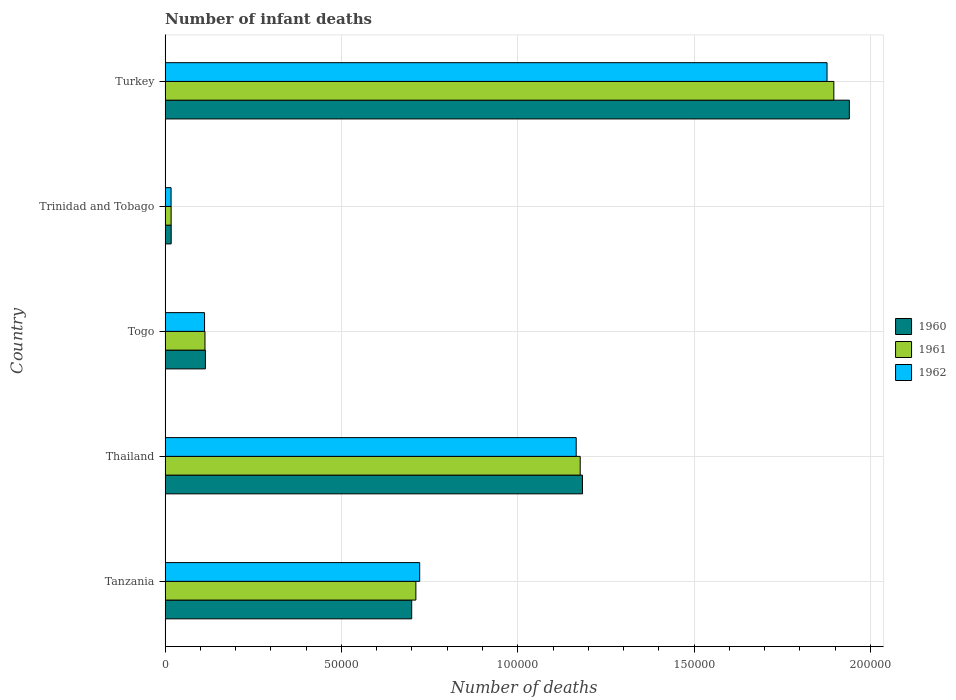Are the number of bars per tick equal to the number of legend labels?
Offer a terse response. Yes. Are the number of bars on each tick of the Y-axis equal?
Give a very brief answer. Yes. What is the label of the 3rd group of bars from the top?
Your answer should be compact. Togo. In how many cases, is the number of bars for a given country not equal to the number of legend labels?
Offer a very short reply. 0. What is the number of infant deaths in 1960 in Thailand?
Keep it short and to the point. 1.18e+05. Across all countries, what is the maximum number of infant deaths in 1960?
Offer a terse response. 1.94e+05. Across all countries, what is the minimum number of infant deaths in 1961?
Your answer should be compact. 1710. In which country was the number of infant deaths in 1961 minimum?
Offer a very short reply. Trinidad and Tobago. What is the total number of infant deaths in 1962 in the graph?
Give a very brief answer. 3.89e+05. What is the difference between the number of infant deaths in 1960 in Thailand and that in Turkey?
Your response must be concise. -7.57e+04. What is the difference between the number of infant deaths in 1961 in Togo and the number of infant deaths in 1962 in Trinidad and Tobago?
Offer a terse response. 9613. What is the average number of infant deaths in 1960 per country?
Provide a short and direct response. 7.91e+04. What is the difference between the number of infant deaths in 1960 and number of infant deaths in 1961 in Trinidad and Tobago?
Offer a terse response. 18. In how many countries, is the number of infant deaths in 1962 greater than 80000 ?
Ensure brevity in your answer.  2. What is the ratio of the number of infant deaths in 1961 in Thailand to that in Togo?
Offer a very short reply. 10.41. Is the number of infant deaths in 1961 in Togo less than that in Trinidad and Tobago?
Offer a very short reply. No. Is the difference between the number of infant deaths in 1960 in Tanzania and Thailand greater than the difference between the number of infant deaths in 1961 in Tanzania and Thailand?
Provide a short and direct response. No. What is the difference between the highest and the second highest number of infant deaths in 1962?
Make the answer very short. 7.11e+04. What is the difference between the highest and the lowest number of infant deaths in 1962?
Your answer should be very brief. 1.86e+05. In how many countries, is the number of infant deaths in 1961 greater than the average number of infant deaths in 1961 taken over all countries?
Your response must be concise. 2. What does the 2nd bar from the top in Turkey represents?
Provide a succinct answer. 1961. What does the 3rd bar from the bottom in Thailand represents?
Your answer should be compact. 1962. Is it the case that in every country, the sum of the number of infant deaths in 1962 and number of infant deaths in 1961 is greater than the number of infant deaths in 1960?
Your answer should be compact. Yes. What is the difference between two consecutive major ticks on the X-axis?
Provide a short and direct response. 5.00e+04. Are the values on the major ticks of X-axis written in scientific E-notation?
Ensure brevity in your answer.  No. Does the graph contain any zero values?
Make the answer very short. No. Does the graph contain grids?
Give a very brief answer. Yes. What is the title of the graph?
Make the answer very short. Number of infant deaths. Does "1992" appear as one of the legend labels in the graph?
Give a very brief answer. No. What is the label or title of the X-axis?
Your answer should be very brief. Number of deaths. What is the Number of deaths in 1960 in Tanzania?
Make the answer very short. 6.99e+04. What is the Number of deaths of 1961 in Tanzania?
Your response must be concise. 7.11e+04. What is the Number of deaths in 1962 in Tanzania?
Your response must be concise. 7.22e+04. What is the Number of deaths of 1960 in Thailand?
Provide a succinct answer. 1.18e+05. What is the Number of deaths of 1961 in Thailand?
Give a very brief answer. 1.18e+05. What is the Number of deaths in 1962 in Thailand?
Give a very brief answer. 1.17e+05. What is the Number of deaths in 1960 in Togo?
Make the answer very short. 1.14e+04. What is the Number of deaths of 1961 in Togo?
Provide a short and direct response. 1.13e+04. What is the Number of deaths in 1962 in Togo?
Keep it short and to the point. 1.12e+04. What is the Number of deaths of 1960 in Trinidad and Tobago?
Ensure brevity in your answer.  1728. What is the Number of deaths of 1961 in Trinidad and Tobago?
Offer a terse response. 1710. What is the Number of deaths in 1962 in Trinidad and Tobago?
Ensure brevity in your answer.  1698. What is the Number of deaths of 1960 in Turkey?
Ensure brevity in your answer.  1.94e+05. What is the Number of deaths in 1961 in Turkey?
Give a very brief answer. 1.90e+05. What is the Number of deaths in 1962 in Turkey?
Make the answer very short. 1.88e+05. Across all countries, what is the maximum Number of deaths of 1960?
Keep it short and to the point. 1.94e+05. Across all countries, what is the maximum Number of deaths of 1961?
Make the answer very short. 1.90e+05. Across all countries, what is the maximum Number of deaths of 1962?
Provide a short and direct response. 1.88e+05. Across all countries, what is the minimum Number of deaths of 1960?
Offer a terse response. 1728. Across all countries, what is the minimum Number of deaths in 1961?
Offer a terse response. 1710. Across all countries, what is the minimum Number of deaths in 1962?
Give a very brief answer. 1698. What is the total Number of deaths of 1960 in the graph?
Ensure brevity in your answer.  3.95e+05. What is the total Number of deaths in 1961 in the graph?
Make the answer very short. 3.91e+05. What is the total Number of deaths of 1962 in the graph?
Provide a succinct answer. 3.89e+05. What is the difference between the Number of deaths of 1960 in Tanzania and that in Thailand?
Make the answer very short. -4.84e+04. What is the difference between the Number of deaths in 1961 in Tanzania and that in Thailand?
Offer a terse response. -4.66e+04. What is the difference between the Number of deaths of 1962 in Tanzania and that in Thailand?
Provide a succinct answer. -4.44e+04. What is the difference between the Number of deaths of 1960 in Tanzania and that in Togo?
Provide a succinct answer. 5.85e+04. What is the difference between the Number of deaths in 1961 in Tanzania and that in Togo?
Give a very brief answer. 5.98e+04. What is the difference between the Number of deaths of 1962 in Tanzania and that in Togo?
Offer a very short reply. 6.10e+04. What is the difference between the Number of deaths of 1960 in Tanzania and that in Trinidad and Tobago?
Your answer should be compact. 6.82e+04. What is the difference between the Number of deaths of 1961 in Tanzania and that in Trinidad and Tobago?
Ensure brevity in your answer.  6.94e+04. What is the difference between the Number of deaths in 1962 in Tanzania and that in Trinidad and Tobago?
Give a very brief answer. 7.05e+04. What is the difference between the Number of deaths in 1960 in Tanzania and that in Turkey?
Keep it short and to the point. -1.24e+05. What is the difference between the Number of deaths of 1961 in Tanzania and that in Turkey?
Provide a succinct answer. -1.19e+05. What is the difference between the Number of deaths of 1962 in Tanzania and that in Turkey?
Provide a short and direct response. -1.16e+05. What is the difference between the Number of deaths in 1960 in Thailand and that in Togo?
Ensure brevity in your answer.  1.07e+05. What is the difference between the Number of deaths of 1961 in Thailand and that in Togo?
Your response must be concise. 1.06e+05. What is the difference between the Number of deaths of 1962 in Thailand and that in Togo?
Ensure brevity in your answer.  1.05e+05. What is the difference between the Number of deaths of 1960 in Thailand and that in Trinidad and Tobago?
Provide a short and direct response. 1.17e+05. What is the difference between the Number of deaths of 1961 in Thailand and that in Trinidad and Tobago?
Provide a succinct answer. 1.16e+05. What is the difference between the Number of deaths of 1962 in Thailand and that in Trinidad and Tobago?
Your answer should be very brief. 1.15e+05. What is the difference between the Number of deaths of 1960 in Thailand and that in Turkey?
Ensure brevity in your answer.  -7.57e+04. What is the difference between the Number of deaths of 1961 in Thailand and that in Turkey?
Your response must be concise. -7.19e+04. What is the difference between the Number of deaths of 1962 in Thailand and that in Turkey?
Make the answer very short. -7.11e+04. What is the difference between the Number of deaths in 1960 in Togo and that in Trinidad and Tobago?
Keep it short and to the point. 9703. What is the difference between the Number of deaths of 1961 in Togo and that in Trinidad and Tobago?
Ensure brevity in your answer.  9601. What is the difference between the Number of deaths in 1962 in Togo and that in Trinidad and Tobago?
Offer a terse response. 9487. What is the difference between the Number of deaths in 1960 in Togo and that in Turkey?
Make the answer very short. -1.83e+05. What is the difference between the Number of deaths in 1961 in Togo and that in Turkey?
Offer a very short reply. -1.78e+05. What is the difference between the Number of deaths of 1962 in Togo and that in Turkey?
Offer a very short reply. -1.77e+05. What is the difference between the Number of deaths in 1960 in Trinidad and Tobago and that in Turkey?
Keep it short and to the point. -1.92e+05. What is the difference between the Number of deaths of 1961 in Trinidad and Tobago and that in Turkey?
Keep it short and to the point. -1.88e+05. What is the difference between the Number of deaths in 1962 in Trinidad and Tobago and that in Turkey?
Provide a short and direct response. -1.86e+05. What is the difference between the Number of deaths of 1960 in Tanzania and the Number of deaths of 1961 in Thailand?
Your response must be concise. -4.78e+04. What is the difference between the Number of deaths of 1960 in Tanzania and the Number of deaths of 1962 in Thailand?
Provide a succinct answer. -4.66e+04. What is the difference between the Number of deaths of 1961 in Tanzania and the Number of deaths of 1962 in Thailand?
Offer a terse response. -4.55e+04. What is the difference between the Number of deaths of 1960 in Tanzania and the Number of deaths of 1961 in Togo?
Offer a terse response. 5.86e+04. What is the difference between the Number of deaths of 1960 in Tanzania and the Number of deaths of 1962 in Togo?
Give a very brief answer. 5.87e+04. What is the difference between the Number of deaths in 1961 in Tanzania and the Number of deaths in 1962 in Togo?
Make the answer very short. 5.99e+04. What is the difference between the Number of deaths of 1960 in Tanzania and the Number of deaths of 1961 in Trinidad and Tobago?
Offer a very short reply. 6.82e+04. What is the difference between the Number of deaths of 1960 in Tanzania and the Number of deaths of 1962 in Trinidad and Tobago?
Your answer should be very brief. 6.82e+04. What is the difference between the Number of deaths of 1961 in Tanzania and the Number of deaths of 1962 in Trinidad and Tobago?
Make the answer very short. 6.94e+04. What is the difference between the Number of deaths of 1960 in Tanzania and the Number of deaths of 1961 in Turkey?
Offer a very short reply. -1.20e+05. What is the difference between the Number of deaths of 1960 in Tanzania and the Number of deaths of 1962 in Turkey?
Your answer should be compact. -1.18e+05. What is the difference between the Number of deaths of 1961 in Tanzania and the Number of deaths of 1962 in Turkey?
Provide a short and direct response. -1.17e+05. What is the difference between the Number of deaths in 1960 in Thailand and the Number of deaths in 1961 in Togo?
Offer a very short reply. 1.07e+05. What is the difference between the Number of deaths of 1960 in Thailand and the Number of deaths of 1962 in Togo?
Your response must be concise. 1.07e+05. What is the difference between the Number of deaths in 1961 in Thailand and the Number of deaths in 1962 in Togo?
Your response must be concise. 1.07e+05. What is the difference between the Number of deaths in 1960 in Thailand and the Number of deaths in 1961 in Trinidad and Tobago?
Offer a terse response. 1.17e+05. What is the difference between the Number of deaths of 1960 in Thailand and the Number of deaths of 1962 in Trinidad and Tobago?
Your response must be concise. 1.17e+05. What is the difference between the Number of deaths of 1961 in Thailand and the Number of deaths of 1962 in Trinidad and Tobago?
Make the answer very short. 1.16e+05. What is the difference between the Number of deaths of 1960 in Thailand and the Number of deaths of 1961 in Turkey?
Your response must be concise. -7.13e+04. What is the difference between the Number of deaths in 1960 in Thailand and the Number of deaths in 1962 in Turkey?
Ensure brevity in your answer.  -6.93e+04. What is the difference between the Number of deaths in 1961 in Thailand and the Number of deaths in 1962 in Turkey?
Make the answer very short. -7.00e+04. What is the difference between the Number of deaths in 1960 in Togo and the Number of deaths in 1961 in Trinidad and Tobago?
Provide a succinct answer. 9721. What is the difference between the Number of deaths of 1960 in Togo and the Number of deaths of 1962 in Trinidad and Tobago?
Keep it short and to the point. 9733. What is the difference between the Number of deaths in 1961 in Togo and the Number of deaths in 1962 in Trinidad and Tobago?
Keep it short and to the point. 9613. What is the difference between the Number of deaths of 1960 in Togo and the Number of deaths of 1961 in Turkey?
Offer a terse response. -1.78e+05. What is the difference between the Number of deaths in 1960 in Togo and the Number of deaths in 1962 in Turkey?
Keep it short and to the point. -1.76e+05. What is the difference between the Number of deaths in 1961 in Togo and the Number of deaths in 1962 in Turkey?
Make the answer very short. -1.76e+05. What is the difference between the Number of deaths in 1960 in Trinidad and Tobago and the Number of deaths in 1961 in Turkey?
Your answer should be compact. -1.88e+05. What is the difference between the Number of deaths of 1960 in Trinidad and Tobago and the Number of deaths of 1962 in Turkey?
Make the answer very short. -1.86e+05. What is the difference between the Number of deaths in 1961 in Trinidad and Tobago and the Number of deaths in 1962 in Turkey?
Provide a short and direct response. -1.86e+05. What is the average Number of deaths of 1960 per country?
Offer a very short reply. 7.91e+04. What is the average Number of deaths of 1961 per country?
Offer a very short reply. 7.83e+04. What is the average Number of deaths in 1962 per country?
Provide a succinct answer. 7.79e+04. What is the difference between the Number of deaths in 1960 and Number of deaths in 1961 in Tanzania?
Your answer should be compact. -1186. What is the difference between the Number of deaths of 1960 and Number of deaths of 1962 in Tanzania?
Offer a very short reply. -2266. What is the difference between the Number of deaths of 1961 and Number of deaths of 1962 in Tanzania?
Give a very brief answer. -1080. What is the difference between the Number of deaths of 1960 and Number of deaths of 1961 in Thailand?
Give a very brief answer. 643. What is the difference between the Number of deaths in 1960 and Number of deaths in 1962 in Thailand?
Give a very brief answer. 1775. What is the difference between the Number of deaths in 1961 and Number of deaths in 1962 in Thailand?
Give a very brief answer. 1132. What is the difference between the Number of deaths in 1960 and Number of deaths in 1961 in Togo?
Ensure brevity in your answer.  120. What is the difference between the Number of deaths of 1960 and Number of deaths of 1962 in Togo?
Your answer should be compact. 246. What is the difference between the Number of deaths of 1961 and Number of deaths of 1962 in Togo?
Offer a very short reply. 126. What is the difference between the Number of deaths in 1960 and Number of deaths in 1962 in Trinidad and Tobago?
Your response must be concise. 30. What is the difference between the Number of deaths in 1961 and Number of deaths in 1962 in Trinidad and Tobago?
Give a very brief answer. 12. What is the difference between the Number of deaths in 1960 and Number of deaths in 1961 in Turkey?
Keep it short and to the point. 4395. What is the difference between the Number of deaths in 1960 and Number of deaths in 1962 in Turkey?
Your answer should be very brief. 6326. What is the difference between the Number of deaths in 1961 and Number of deaths in 1962 in Turkey?
Ensure brevity in your answer.  1931. What is the ratio of the Number of deaths in 1960 in Tanzania to that in Thailand?
Make the answer very short. 0.59. What is the ratio of the Number of deaths in 1961 in Tanzania to that in Thailand?
Offer a very short reply. 0.6. What is the ratio of the Number of deaths in 1962 in Tanzania to that in Thailand?
Provide a succinct answer. 0.62. What is the ratio of the Number of deaths of 1960 in Tanzania to that in Togo?
Your answer should be very brief. 6.12. What is the ratio of the Number of deaths of 1961 in Tanzania to that in Togo?
Your response must be concise. 6.29. What is the ratio of the Number of deaths of 1962 in Tanzania to that in Togo?
Keep it short and to the point. 6.45. What is the ratio of the Number of deaths of 1960 in Tanzania to that in Trinidad and Tobago?
Your answer should be compact. 40.47. What is the ratio of the Number of deaths in 1961 in Tanzania to that in Trinidad and Tobago?
Ensure brevity in your answer.  41.59. What is the ratio of the Number of deaths of 1962 in Tanzania to that in Trinidad and Tobago?
Keep it short and to the point. 42.52. What is the ratio of the Number of deaths of 1960 in Tanzania to that in Turkey?
Keep it short and to the point. 0.36. What is the ratio of the Number of deaths of 1962 in Tanzania to that in Turkey?
Provide a succinct answer. 0.38. What is the ratio of the Number of deaths in 1960 in Thailand to that in Togo?
Provide a succinct answer. 10.35. What is the ratio of the Number of deaths of 1961 in Thailand to that in Togo?
Your answer should be very brief. 10.41. What is the ratio of the Number of deaths in 1962 in Thailand to that in Togo?
Provide a short and direct response. 10.42. What is the ratio of the Number of deaths of 1960 in Thailand to that in Trinidad and Tobago?
Keep it short and to the point. 68.49. What is the ratio of the Number of deaths of 1961 in Thailand to that in Trinidad and Tobago?
Offer a very short reply. 68.83. What is the ratio of the Number of deaths in 1962 in Thailand to that in Trinidad and Tobago?
Offer a terse response. 68.65. What is the ratio of the Number of deaths in 1960 in Thailand to that in Turkey?
Ensure brevity in your answer.  0.61. What is the ratio of the Number of deaths of 1961 in Thailand to that in Turkey?
Make the answer very short. 0.62. What is the ratio of the Number of deaths in 1962 in Thailand to that in Turkey?
Your response must be concise. 0.62. What is the ratio of the Number of deaths of 1960 in Togo to that in Trinidad and Tobago?
Your answer should be very brief. 6.62. What is the ratio of the Number of deaths in 1961 in Togo to that in Trinidad and Tobago?
Your answer should be compact. 6.61. What is the ratio of the Number of deaths in 1962 in Togo to that in Trinidad and Tobago?
Offer a terse response. 6.59. What is the ratio of the Number of deaths in 1960 in Togo to that in Turkey?
Offer a terse response. 0.06. What is the ratio of the Number of deaths in 1961 in Togo to that in Turkey?
Ensure brevity in your answer.  0.06. What is the ratio of the Number of deaths in 1962 in Togo to that in Turkey?
Offer a very short reply. 0.06. What is the ratio of the Number of deaths of 1960 in Trinidad and Tobago to that in Turkey?
Your answer should be very brief. 0.01. What is the ratio of the Number of deaths in 1961 in Trinidad and Tobago to that in Turkey?
Your response must be concise. 0.01. What is the ratio of the Number of deaths of 1962 in Trinidad and Tobago to that in Turkey?
Your answer should be very brief. 0.01. What is the difference between the highest and the second highest Number of deaths of 1960?
Your answer should be very brief. 7.57e+04. What is the difference between the highest and the second highest Number of deaths of 1961?
Your response must be concise. 7.19e+04. What is the difference between the highest and the second highest Number of deaths of 1962?
Your answer should be very brief. 7.11e+04. What is the difference between the highest and the lowest Number of deaths of 1960?
Provide a succinct answer. 1.92e+05. What is the difference between the highest and the lowest Number of deaths of 1961?
Provide a short and direct response. 1.88e+05. What is the difference between the highest and the lowest Number of deaths of 1962?
Make the answer very short. 1.86e+05. 